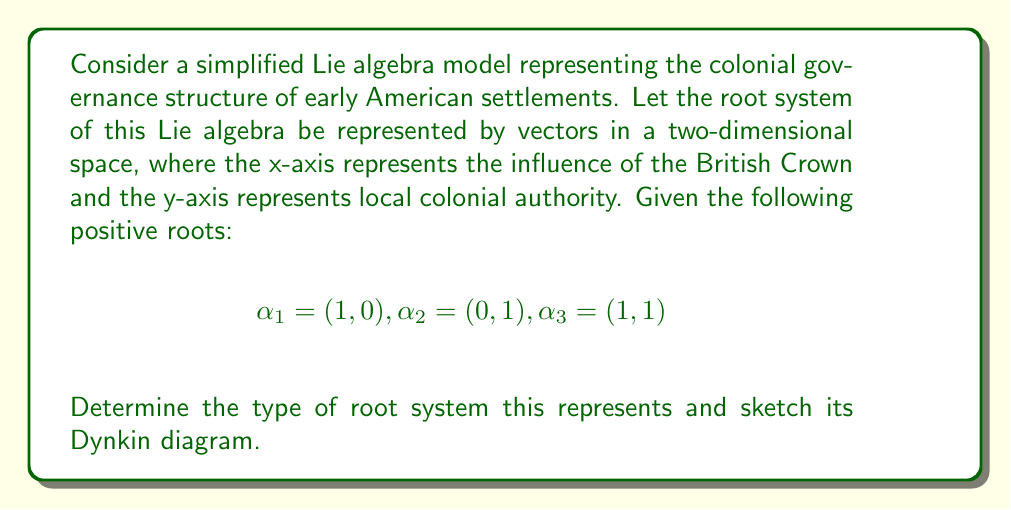Give your solution to this math problem. To solve this problem, we'll follow these steps:

1) Identify the rank of the Lie algebra:
   The rank is the dimension of the root space, which is 2 in this case.

2) Analyze the root system:
   We have three positive roots: $\alpha_1$, $\alpha_2$, and $\alpha_3$.
   $\alpha_3 = \alpha_1 + \alpha_2$, which is a characteristic of the $A_2$ root system.

3) Check the angles between roots:
   The angle between $\alpha_1$ and $\alpha_2$ is 90°, which is consistent with $A_2$.

4) Confirm it's not another rank 2 system:
   It's not $B_2$, $C_2$, or $G_2$ because those have roots of different lengths.

5) Construct the Dynkin diagram:
   - Draw two nodes representing $\alpha_1$ and $\alpha_2$.
   - Connect them with a single line, as the angle between them is 120°.

[asy]
unitsize(1cm);
dot((0,0));
dot((1,0));
draw((0,0)--(1,0));
label("$\alpha_1$", (0,0), SW);
label("$\alpha_2$", (1,0), SE);
[/asy]

This root system and Dynkin diagram correspond to the Lie algebra $\mathfrak{sl}(3, \mathbb{C})$, which is of type $A_2$.

In the context of colonial governance, this could be interpreted as:
- $\alpha_1$: British Crown's direct influence
- $\alpha_2$: Local colonial authority
- $\alpha_3$: Shared governance between Crown and colony

The $A_2$ structure suggests a balanced, two-tiered system of governance in early American colonies.
Answer: The root system represents the Lie algebra $\mathfrak{sl}(3, \mathbb{C})$ of type $A_2$. Its Dynkin diagram consists of two nodes connected by a single line. 